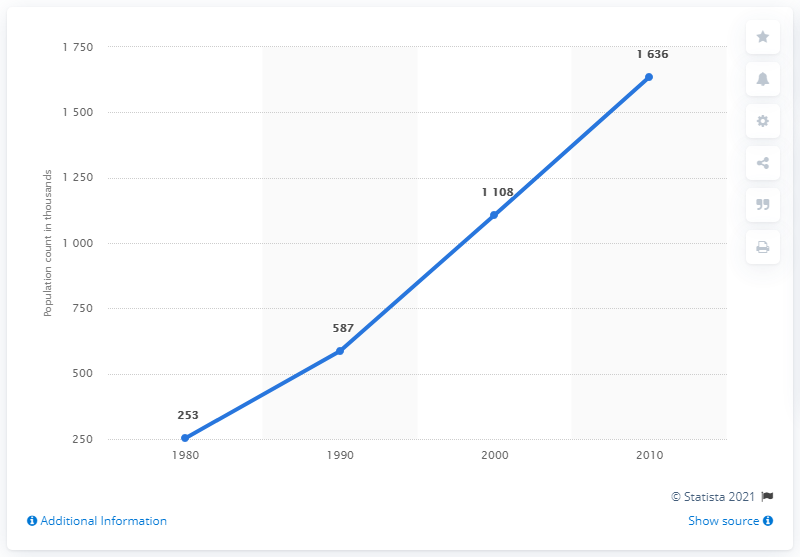Highlight a few significant elements in this photo. The difference between the change in the US Vietnamese population between the years 2010 and 1980 is 1383. The change in the US Vietnamese population in the year 1990 was 587. 